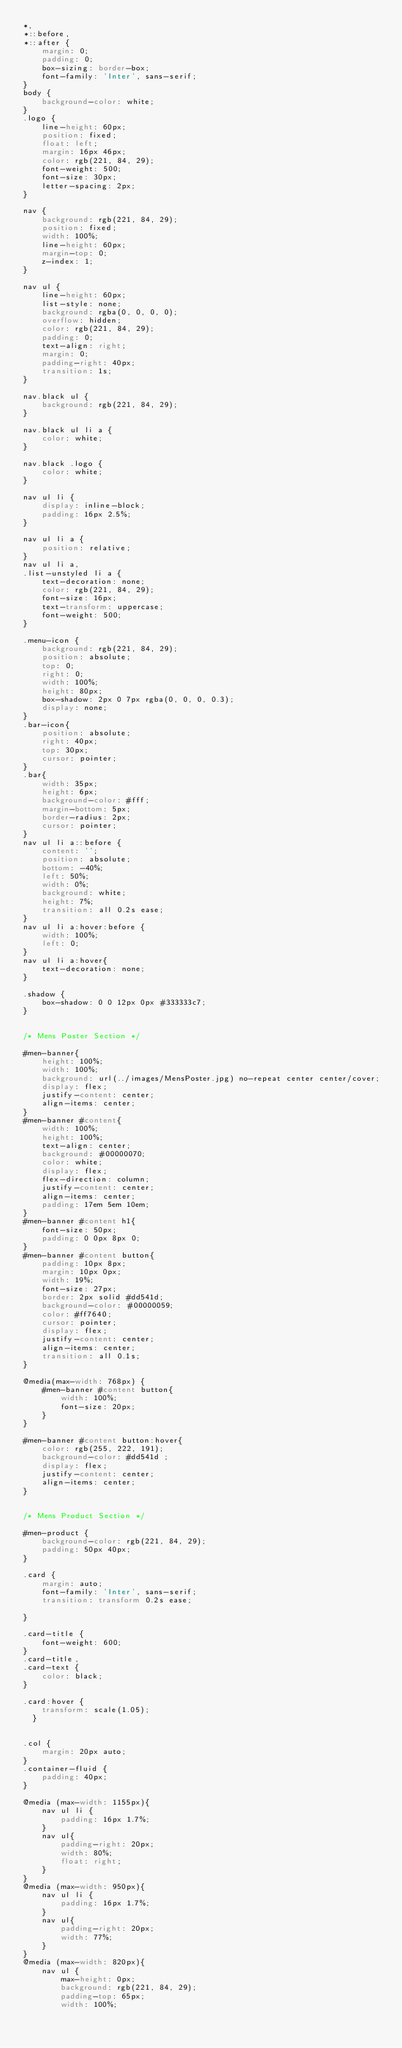<code> <loc_0><loc_0><loc_500><loc_500><_CSS_>*,
*::before,
*::after {
    margin: 0;
    padding: 0;
    box-sizing: border-box;
    font-family: 'Inter', sans-serif;
}
body {
    background-color: white;
}
.logo {
    line-height: 60px;
    position: fixed;
    float: left;
    margin: 16px 46px;
    color: rgb(221, 84, 29);
    font-weight: 500;
    font-size: 30px;
    letter-spacing: 2px;
}

nav {
    background: rgb(221, 84, 29);
    position: fixed;
    width: 100%;
    line-height: 60px;
    margin-top: 0;
    z-index: 1;
}

nav ul {
    line-height: 60px;
    list-style: none;
    background: rgba(0, 0, 0, 0);
    overflow: hidden;
    color: rgb(221, 84, 29);
    padding: 0;
    text-align: right;
    margin: 0;
    padding-right: 40px;
    transition: 1s;
}

nav.black ul {
    background: rgb(221, 84, 29);
}

nav.black ul li a {
    color: white;
}

nav.black .logo {
    color: white;
}

nav ul li {
    display: inline-block;
    padding: 16px 2.5%;
}

nav ul li a {
    position: relative;
}
nav ul li a,
.list-unstyled li a {
    text-decoration: none;
    color: rgb(221, 84, 29);
    font-size: 16px;
    text-transform: uppercase;
    font-weight: 500;
}

.menu-icon {
    background: rgb(221, 84, 29);
    position: absolute;
    top: 0;
    right: 0;
    width: 100%;
    height: 80px;
    box-shadow: 2px 0 7px rgba(0, 0, 0, 0.3);
    display: none;
}
.bar-icon{
    position: absolute;
    right: 40px;
    top: 30px;
    cursor: pointer;
}
.bar{
    width: 35px;
    height: 6px;
    background-color: #fff;
    margin-bottom: 5px;
    border-radius: 2px;
    cursor: pointer;
}
nav ul li a::before {
    content: '';
    position: absolute;
    bottom: -40%;
    left: 50%;
    width: 0%;
    background: white;
    height: 7%;
    transition: all 0.2s ease;
}
nav ul li a:hover:before {
    width: 100%;
    left: 0;
}
nav ul li a:hover{
    text-decoration: none;
}

.shadow {
    box-shadow: 0 0 12px 0px #333333c7;
}


/* Mens Poster Section */

#men-banner{
    height: 100%;
    width: 100%;
    background: url(../images/MensPoster.jpg) no-repeat center center/cover;
    display: flex;
    justify-content: center;
    align-items: center;
}
#men-banner #content{
    width: 100%;
    height: 100%;
    text-align: center;
    background: #00000070;
    color: white;
    display: flex;
    flex-direction: column;
    justify-content: center;
    align-items: center;
    padding: 17em 5em 10em;
}
#men-banner #content h1{
    font-size: 50px;
    padding: 0 0px 8px 0;
}
#men-banner #content button{
    padding: 10px 8px;
    margin: 10px 0px;
    width: 19%;
    font-size: 27px;
    border: 2px solid #dd541d;
    background-color: #00000059;
    color: #ff7640;
    cursor: pointer;
    display: flex;
    justify-content: center;
    align-items: center;
    transition: all 0.1s;
}

@media(max-width: 768px) {
    #men-banner #content button{
        width: 100%;  
        font-size: 20px;
    }
}

#men-banner #content button:hover{
    color: rgb(255, 222, 191);
    background-color: #dd541d ;
    display: flex;
    justify-content: center;
    align-items: center;
}


/* Mens Product Section */

#men-product {
    background-color: rgb(221, 84, 29);
    padding: 50px 40px;
}

.card {
    margin: auto;
    font-family: 'Inter', sans-serif;
    transition: transform 0.2s ease;

}

.card-title {
    font-weight: 600;
}
.card-title,
.card-text {
    color: black;
}

.card:hover {
    transform: scale(1.05);
  }
  

.col {
    margin: 20px auto;
}
.container-fluid {
    padding: 40px;
}

@media (max-width: 1155px){
    nav ul li {
        padding: 16px 1.7%;
    }
    nav ul{
        padding-right: 20px;
        width: 80%;
        float: right;
    }
}
@media (max-width: 950px){
    nav ul li {
        padding: 16px 1.7%;
    }
    nav ul{
        padding-right: 20px;
        width: 77%;
    }
}
@media (max-width: 820px){
    nav ul {
        max-height: 0px;
        background: rgb(221, 84, 29);
        padding-top: 65px;
        width: 100%;</code> 